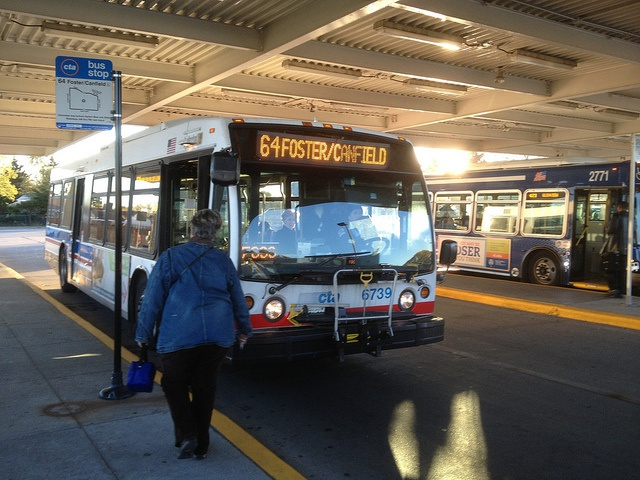Describe the objects in this image and their specific colors. I can see bus in gray, black, lightgray, and darkgray tones, bus in gray, black, tan, and beige tones, people in gray, black, navy, and darkblue tones, people in gray, darkgray, black, and lightblue tones, and people in gray and black tones in this image. 